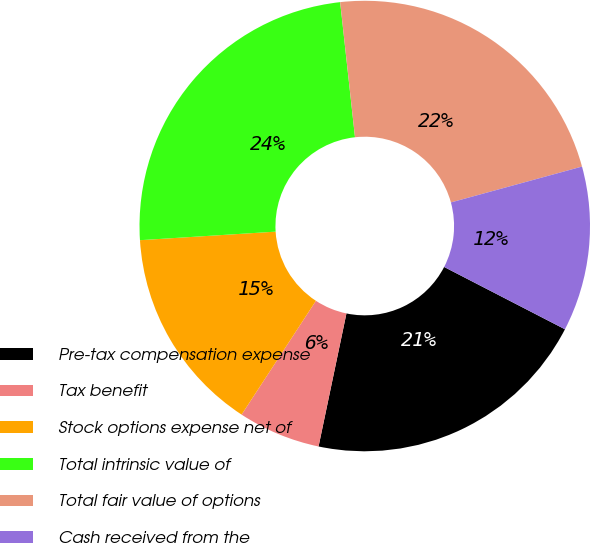Convert chart. <chart><loc_0><loc_0><loc_500><loc_500><pie_chart><fcel>Pre-tax compensation expense<fcel>Tax benefit<fcel>Stock options expense net of<fcel>Total intrinsic value of<fcel>Total fair value of options<fcel>Cash received from the<nl><fcel>20.71%<fcel>5.92%<fcel>14.79%<fcel>24.26%<fcel>22.49%<fcel>11.83%<nl></chart> 